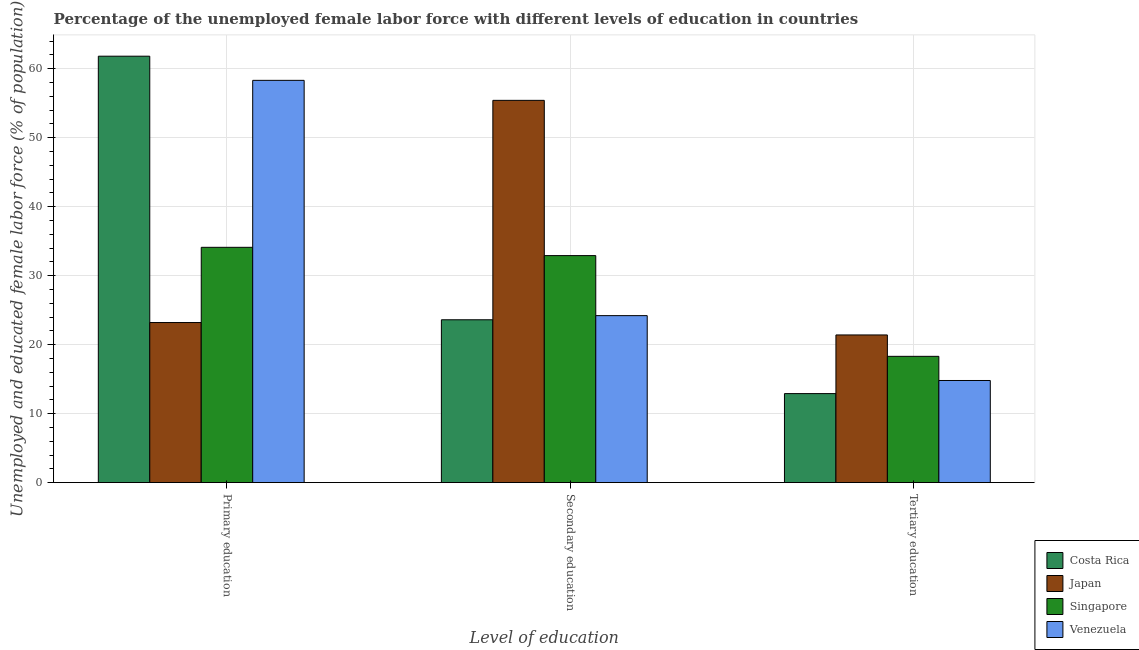How many groups of bars are there?
Your answer should be compact. 3. Are the number of bars on each tick of the X-axis equal?
Provide a succinct answer. Yes. How many bars are there on the 3rd tick from the left?
Give a very brief answer. 4. How many bars are there on the 2nd tick from the right?
Your response must be concise. 4. What is the label of the 3rd group of bars from the left?
Make the answer very short. Tertiary education. What is the percentage of female labor force who received secondary education in Singapore?
Provide a succinct answer. 32.9. Across all countries, what is the maximum percentage of female labor force who received secondary education?
Ensure brevity in your answer.  55.4. Across all countries, what is the minimum percentage of female labor force who received secondary education?
Offer a terse response. 23.6. What is the total percentage of female labor force who received secondary education in the graph?
Your response must be concise. 136.1. What is the difference between the percentage of female labor force who received primary education in Singapore and that in Costa Rica?
Your response must be concise. -27.7. What is the difference between the percentage of female labor force who received secondary education in Japan and the percentage of female labor force who received tertiary education in Costa Rica?
Give a very brief answer. 42.5. What is the average percentage of female labor force who received secondary education per country?
Offer a very short reply. 34.03. What is the difference between the percentage of female labor force who received primary education and percentage of female labor force who received secondary education in Japan?
Make the answer very short. -32.2. What is the ratio of the percentage of female labor force who received primary education in Japan to that in Costa Rica?
Your answer should be compact. 0.38. What is the difference between the highest and the second highest percentage of female labor force who received tertiary education?
Give a very brief answer. 3.1. What is the difference between the highest and the lowest percentage of female labor force who received primary education?
Your answer should be compact. 38.6. What does the 1st bar from the left in Secondary education represents?
Your answer should be very brief. Costa Rica. What does the 1st bar from the right in Secondary education represents?
Make the answer very short. Venezuela. Are all the bars in the graph horizontal?
Give a very brief answer. No. How many countries are there in the graph?
Give a very brief answer. 4. What is the difference between two consecutive major ticks on the Y-axis?
Keep it short and to the point. 10. Are the values on the major ticks of Y-axis written in scientific E-notation?
Make the answer very short. No. Does the graph contain grids?
Offer a very short reply. Yes. What is the title of the graph?
Offer a terse response. Percentage of the unemployed female labor force with different levels of education in countries. What is the label or title of the X-axis?
Offer a very short reply. Level of education. What is the label or title of the Y-axis?
Offer a terse response. Unemployed and educated female labor force (% of population). What is the Unemployed and educated female labor force (% of population) of Costa Rica in Primary education?
Keep it short and to the point. 61.8. What is the Unemployed and educated female labor force (% of population) of Japan in Primary education?
Provide a short and direct response. 23.2. What is the Unemployed and educated female labor force (% of population) in Singapore in Primary education?
Your answer should be very brief. 34.1. What is the Unemployed and educated female labor force (% of population) of Venezuela in Primary education?
Give a very brief answer. 58.3. What is the Unemployed and educated female labor force (% of population) in Costa Rica in Secondary education?
Offer a terse response. 23.6. What is the Unemployed and educated female labor force (% of population) of Japan in Secondary education?
Keep it short and to the point. 55.4. What is the Unemployed and educated female labor force (% of population) of Singapore in Secondary education?
Keep it short and to the point. 32.9. What is the Unemployed and educated female labor force (% of population) of Venezuela in Secondary education?
Offer a very short reply. 24.2. What is the Unemployed and educated female labor force (% of population) in Costa Rica in Tertiary education?
Offer a terse response. 12.9. What is the Unemployed and educated female labor force (% of population) of Japan in Tertiary education?
Ensure brevity in your answer.  21.4. What is the Unemployed and educated female labor force (% of population) in Singapore in Tertiary education?
Your answer should be compact. 18.3. What is the Unemployed and educated female labor force (% of population) in Venezuela in Tertiary education?
Provide a short and direct response. 14.8. Across all Level of education, what is the maximum Unemployed and educated female labor force (% of population) of Costa Rica?
Offer a terse response. 61.8. Across all Level of education, what is the maximum Unemployed and educated female labor force (% of population) of Japan?
Make the answer very short. 55.4. Across all Level of education, what is the maximum Unemployed and educated female labor force (% of population) in Singapore?
Keep it short and to the point. 34.1. Across all Level of education, what is the maximum Unemployed and educated female labor force (% of population) in Venezuela?
Provide a short and direct response. 58.3. Across all Level of education, what is the minimum Unemployed and educated female labor force (% of population) in Costa Rica?
Your response must be concise. 12.9. Across all Level of education, what is the minimum Unemployed and educated female labor force (% of population) of Japan?
Your answer should be very brief. 21.4. Across all Level of education, what is the minimum Unemployed and educated female labor force (% of population) in Singapore?
Ensure brevity in your answer.  18.3. Across all Level of education, what is the minimum Unemployed and educated female labor force (% of population) of Venezuela?
Keep it short and to the point. 14.8. What is the total Unemployed and educated female labor force (% of population) in Costa Rica in the graph?
Provide a short and direct response. 98.3. What is the total Unemployed and educated female labor force (% of population) in Singapore in the graph?
Keep it short and to the point. 85.3. What is the total Unemployed and educated female labor force (% of population) in Venezuela in the graph?
Provide a succinct answer. 97.3. What is the difference between the Unemployed and educated female labor force (% of population) of Costa Rica in Primary education and that in Secondary education?
Ensure brevity in your answer.  38.2. What is the difference between the Unemployed and educated female labor force (% of population) in Japan in Primary education and that in Secondary education?
Your response must be concise. -32.2. What is the difference between the Unemployed and educated female labor force (% of population) in Singapore in Primary education and that in Secondary education?
Ensure brevity in your answer.  1.2. What is the difference between the Unemployed and educated female labor force (% of population) of Venezuela in Primary education and that in Secondary education?
Make the answer very short. 34.1. What is the difference between the Unemployed and educated female labor force (% of population) of Costa Rica in Primary education and that in Tertiary education?
Ensure brevity in your answer.  48.9. What is the difference between the Unemployed and educated female labor force (% of population) of Venezuela in Primary education and that in Tertiary education?
Provide a short and direct response. 43.5. What is the difference between the Unemployed and educated female labor force (% of population) in Costa Rica in Secondary education and that in Tertiary education?
Provide a succinct answer. 10.7. What is the difference between the Unemployed and educated female labor force (% of population) in Japan in Secondary education and that in Tertiary education?
Your answer should be very brief. 34. What is the difference between the Unemployed and educated female labor force (% of population) of Venezuela in Secondary education and that in Tertiary education?
Provide a short and direct response. 9.4. What is the difference between the Unemployed and educated female labor force (% of population) of Costa Rica in Primary education and the Unemployed and educated female labor force (% of population) of Singapore in Secondary education?
Offer a terse response. 28.9. What is the difference between the Unemployed and educated female labor force (% of population) in Costa Rica in Primary education and the Unemployed and educated female labor force (% of population) in Venezuela in Secondary education?
Your answer should be very brief. 37.6. What is the difference between the Unemployed and educated female labor force (% of population) of Japan in Primary education and the Unemployed and educated female labor force (% of population) of Singapore in Secondary education?
Your answer should be very brief. -9.7. What is the difference between the Unemployed and educated female labor force (% of population) of Japan in Primary education and the Unemployed and educated female labor force (% of population) of Venezuela in Secondary education?
Ensure brevity in your answer.  -1. What is the difference between the Unemployed and educated female labor force (% of population) in Singapore in Primary education and the Unemployed and educated female labor force (% of population) in Venezuela in Secondary education?
Offer a terse response. 9.9. What is the difference between the Unemployed and educated female labor force (% of population) of Costa Rica in Primary education and the Unemployed and educated female labor force (% of population) of Japan in Tertiary education?
Offer a very short reply. 40.4. What is the difference between the Unemployed and educated female labor force (% of population) of Costa Rica in Primary education and the Unemployed and educated female labor force (% of population) of Singapore in Tertiary education?
Your answer should be very brief. 43.5. What is the difference between the Unemployed and educated female labor force (% of population) in Costa Rica in Primary education and the Unemployed and educated female labor force (% of population) in Venezuela in Tertiary education?
Your answer should be very brief. 47. What is the difference between the Unemployed and educated female labor force (% of population) of Japan in Primary education and the Unemployed and educated female labor force (% of population) of Singapore in Tertiary education?
Provide a succinct answer. 4.9. What is the difference between the Unemployed and educated female labor force (% of population) of Japan in Primary education and the Unemployed and educated female labor force (% of population) of Venezuela in Tertiary education?
Keep it short and to the point. 8.4. What is the difference between the Unemployed and educated female labor force (% of population) in Singapore in Primary education and the Unemployed and educated female labor force (% of population) in Venezuela in Tertiary education?
Make the answer very short. 19.3. What is the difference between the Unemployed and educated female labor force (% of population) in Costa Rica in Secondary education and the Unemployed and educated female labor force (% of population) in Singapore in Tertiary education?
Offer a very short reply. 5.3. What is the difference between the Unemployed and educated female labor force (% of population) of Costa Rica in Secondary education and the Unemployed and educated female labor force (% of population) of Venezuela in Tertiary education?
Give a very brief answer. 8.8. What is the difference between the Unemployed and educated female labor force (% of population) of Japan in Secondary education and the Unemployed and educated female labor force (% of population) of Singapore in Tertiary education?
Keep it short and to the point. 37.1. What is the difference between the Unemployed and educated female labor force (% of population) of Japan in Secondary education and the Unemployed and educated female labor force (% of population) of Venezuela in Tertiary education?
Make the answer very short. 40.6. What is the average Unemployed and educated female labor force (% of population) of Costa Rica per Level of education?
Offer a very short reply. 32.77. What is the average Unemployed and educated female labor force (% of population) of Japan per Level of education?
Offer a very short reply. 33.33. What is the average Unemployed and educated female labor force (% of population) in Singapore per Level of education?
Your response must be concise. 28.43. What is the average Unemployed and educated female labor force (% of population) in Venezuela per Level of education?
Offer a very short reply. 32.43. What is the difference between the Unemployed and educated female labor force (% of population) of Costa Rica and Unemployed and educated female labor force (% of population) of Japan in Primary education?
Offer a very short reply. 38.6. What is the difference between the Unemployed and educated female labor force (% of population) of Costa Rica and Unemployed and educated female labor force (% of population) of Singapore in Primary education?
Provide a short and direct response. 27.7. What is the difference between the Unemployed and educated female labor force (% of population) of Japan and Unemployed and educated female labor force (% of population) of Venezuela in Primary education?
Offer a very short reply. -35.1. What is the difference between the Unemployed and educated female labor force (% of population) in Singapore and Unemployed and educated female labor force (% of population) in Venezuela in Primary education?
Offer a terse response. -24.2. What is the difference between the Unemployed and educated female labor force (% of population) of Costa Rica and Unemployed and educated female labor force (% of population) of Japan in Secondary education?
Provide a succinct answer. -31.8. What is the difference between the Unemployed and educated female labor force (% of population) of Costa Rica and Unemployed and educated female labor force (% of population) of Venezuela in Secondary education?
Provide a succinct answer. -0.6. What is the difference between the Unemployed and educated female labor force (% of population) of Japan and Unemployed and educated female labor force (% of population) of Singapore in Secondary education?
Provide a succinct answer. 22.5. What is the difference between the Unemployed and educated female labor force (% of population) of Japan and Unemployed and educated female labor force (% of population) of Venezuela in Secondary education?
Provide a short and direct response. 31.2. What is the difference between the Unemployed and educated female labor force (% of population) of Singapore and Unemployed and educated female labor force (% of population) of Venezuela in Secondary education?
Your answer should be compact. 8.7. What is the difference between the Unemployed and educated female labor force (% of population) of Costa Rica and Unemployed and educated female labor force (% of population) of Singapore in Tertiary education?
Keep it short and to the point. -5.4. What is the difference between the Unemployed and educated female labor force (% of population) of Costa Rica and Unemployed and educated female labor force (% of population) of Venezuela in Tertiary education?
Give a very brief answer. -1.9. What is the difference between the Unemployed and educated female labor force (% of population) of Japan and Unemployed and educated female labor force (% of population) of Singapore in Tertiary education?
Your answer should be very brief. 3.1. What is the difference between the Unemployed and educated female labor force (% of population) of Japan and Unemployed and educated female labor force (% of population) of Venezuela in Tertiary education?
Offer a very short reply. 6.6. What is the ratio of the Unemployed and educated female labor force (% of population) in Costa Rica in Primary education to that in Secondary education?
Keep it short and to the point. 2.62. What is the ratio of the Unemployed and educated female labor force (% of population) in Japan in Primary education to that in Secondary education?
Make the answer very short. 0.42. What is the ratio of the Unemployed and educated female labor force (% of population) in Singapore in Primary education to that in Secondary education?
Offer a terse response. 1.04. What is the ratio of the Unemployed and educated female labor force (% of population) in Venezuela in Primary education to that in Secondary education?
Ensure brevity in your answer.  2.41. What is the ratio of the Unemployed and educated female labor force (% of population) in Costa Rica in Primary education to that in Tertiary education?
Provide a succinct answer. 4.79. What is the ratio of the Unemployed and educated female labor force (% of population) of Japan in Primary education to that in Tertiary education?
Make the answer very short. 1.08. What is the ratio of the Unemployed and educated female labor force (% of population) of Singapore in Primary education to that in Tertiary education?
Give a very brief answer. 1.86. What is the ratio of the Unemployed and educated female labor force (% of population) in Venezuela in Primary education to that in Tertiary education?
Your answer should be compact. 3.94. What is the ratio of the Unemployed and educated female labor force (% of population) of Costa Rica in Secondary education to that in Tertiary education?
Provide a short and direct response. 1.83. What is the ratio of the Unemployed and educated female labor force (% of population) of Japan in Secondary education to that in Tertiary education?
Your answer should be compact. 2.59. What is the ratio of the Unemployed and educated female labor force (% of population) in Singapore in Secondary education to that in Tertiary education?
Keep it short and to the point. 1.8. What is the ratio of the Unemployed and educated female labor force (% of population) of Venezuela in Secondary education to that in Tertiary education?
Give a very brief answer. 1.64. What is the difference between the highest and the second highest Unemployed and educated female labor force (% of population) of Costa Rica?
Keep it short and to the point. 38.2. What is the difference between the highest and the second highest Unemployed and educated female labor force (% of population) in Japan?
Give a very brief answer. 32.2. What is the difference between the highest and the second highest Unemployed and educated female labor force (% of population) of Singapore?
Make the answer very short. 1.2. What is the difference between the highest and the second highest Unemployed and educated female labor force (% of population) of Venezuela?
Your response must be concise. 34.1. What is the difference between the highest and the lowest Unemployed and educated female labor force (% of population) in Costa Rica?
Offer a very short reply. 48.9. What is the difference between the highest and the lowest Unemployed and educated female labor force (% of population) of Japan?
Offer a terse response. 34. What is the difference between the highest and the lowest Unemployed and educated female labor force (% of population) of Singapore?
Give a very brief answer. 15.8. What is the difference between the highest and the lowest Unemployed and educated female labor force (% of population) of Venezuela?
Make the answer very short. 43.5. 